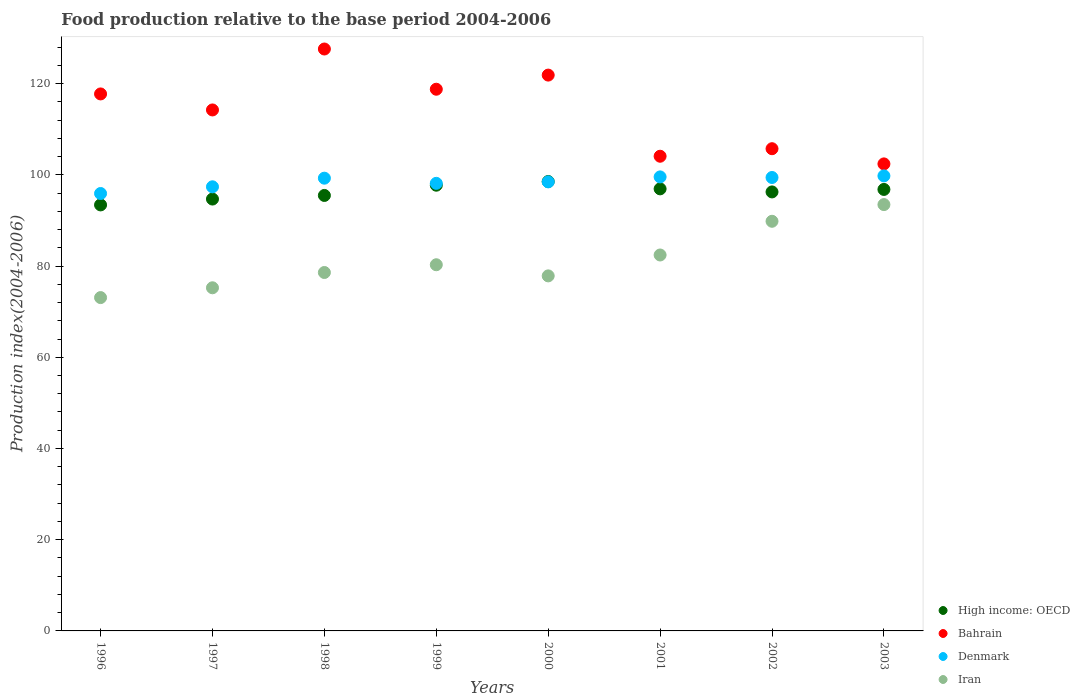Is the number of dotlines equal to the number of legend labels?
Keep it short and to the point. Yes. What is the food production index in Bahrain in 2001?
Give a very brief answer. 104.07. Across all years, what is the maximum food production index in Bahrain?
Make the answer very short. 127.58. Across all years, what is the minimum food production index in Bahrain?
Ensure brevity in your answer.  102.39. In which year was the food production index in Denmark maximum?
Provide a short and direct response. 2003. In which year was the food production index in Bahrain minimum?
Ensure brevity in your answer.  2003. What is the total food production index in Denmark in the graph?
Keep it short and to the point. 787.82. What is the difference between the food production index in Iran in 1996 and that in 1997?
Keep it short and to the point. -2.15. What is the difference between the food production index in Denmark in 2002 and the food production index in High income: OECD in 2001?
Offer a terse response. 2.49. What is the average food production index in Bahrain per year?
Provide a short and direct response. 114.04. In the year 2001, what is the difference between the food production index in High income: OECD and food production index in Denmark?
Your response must be concise. -2.62. What is the ratio of the food production index in Denmark in 1997 to that in 2001?
Your answer should be very brief. 0.98. Is the difference between the food production index in High income: OECD in 1996 and 1998 greater than the difference between the food production index in Denmark in 1996 and 1998?
Your response must be concise. Yes. What is the difference between the highest and the second highest food production index in Denmark?
Provide a short and direct response. 0.22. What is the difference between the highest and the lowest food production index in High income: OECD?
Offer a very short reply. 5.13. In how many years, is the food production index in High income: OECD greater than the average food production index in High income: OECD taken over all years?
Keep it short and to the point. 5. Is the sum of the food production index in Iran in 2000 and 2003 greater than the maximum food production index in Denmark across all years?
Your answer should be compact. Yes. Is it the case that in every year, the sum of the food production index in High income: OECD and food production index in Bahrain  is greater than the food production index in Denmark?
Give a very brief answer. Yes. Does the food production index in Iran monotonically increase over the years?
Provide a succinct answer. No. How many dotlines are there?
Your answer should be very brief. 4. What is the difference between two consecutive major ticks on the Y-axis?
Give a very brief answer. 20. Are the values on the major ticks of Y-axis written in scientific E-notation?
Provide a succinct answer. No. Does the graph contain grids?
Provide a short and direct response. No. Where does the legend appear in the graph?
Offer a terse response. Bottom right. What is the title of the graph?
Make the answer very short. Food production relative to the base period 2004-2006. Does "Barbados" appear as one of the legend labels in the graph?
Ensure brevity in your answer.  No. What is the label or title of the X-axis?
Provide a succinct answer. Years. What is the label or title of the Y-axis?
Keep it short and to the point. Production index(2004-2006). What is the Production index(2004-2006) in High income: OECD in 1996?
Provide a succinct answer. 93.4. What is the Production index(2004-2006) of Bahrain in 1996?
Make the answer very short. 117.73. What is the Production index(2004-2006) of Denmark in 1996?
Provide a short and direct response. 95.9. What is the Production index(2004-2006) of Iran in 1996?
Make the answer very short. 73.08. What is the Production index(2004-2006) of High income: OECD in 1997?
Your response must be concise. 94.68. What is the Production index(2004-2006) of Bahrain in 1997?
Make the answer very short. 114.22. What is the Production index(2004-2006) in Denmark in 1997?
Your answer should be very brief. 97.37. What is the Production index(2004-2006) in Iran in 1997?
Provide a succinct answer. 75.23. What is the Production index(2004-2006) of High income: OECD in 1998?
Make the answer very short. 95.47. What is the Production index(2004-2006) of Bahrain in 1998?
Offer a terse response. 127.58. What is the Production index(2004-2006) of Denmark in 1998?
Your answer should be compact. 99.26. What is the Production index(2004-2006) of Iran in 1998?
Provide a short and direct response. 78.58. What is the Production index(2004-2006) of High income: OECD in 1999?
Ensure brevity in your answer.  97.72. What is the Production index(2004-2006) of Bahrain in 1999?
Offer a very short reply. 118.76. What is the Production index(2004-2006) of Denmark in 1999?
Provide a short and direct response. 98.13. What is the Production index(2004-2006) of Iran in 1999?
Your response must be concise. 80.28. What is the Production index(2004-2006) of High income: OECD in 2000?
Offer a very short reply. 98.53. What is the Production index(2004-2006) in Bahrain in 2000?
Your answer should be very brief. 121.86. What is the Production index(2004-2006) of Denmark in 2000?
Ensure brevity in your answer.  98.45. What is the Production index(2004-2006) of Iran in 2000?
Provide a short and direct response. 77.84. What is the Production index(2004-2006) in High income: OECD in 2001?
Your answer should be compact. 96.92. What is the Production index(2004-2006) in Bahrain in 2001?
Provide a succinct answer. 104.07. What is the Production index(2004-2006) of Denmark in 2001?
Offer a terse response. 99.54. What is the Production index(2004-2006) of Iran in 2001?
Offer a terse response. 82.42. What is the Production index(2004-2006) in High income: OECD in 2002?
Offer a terse response. 96.25. What is the Production index(2004-2006) in Bahrain in 2002?
Offer a very short reply. 105.72. What is the Production index(2004-2006) in Denmark in 2002?
Your answer should be compact. 99.41. What is the Production index(2004-2006) of Iran in 2002?
Offer a terse response. 89.81. What is the Production index(2004-2006) of High income: OECD in 2003?
Your answer should be very brief. 96.79. What is the Production index(2004-2006) in Bahrain in 2003?
Ensure brevity in your answer.  102.39. What is the Production index(2004-2006) in Denmark in 2003?
Your answer should be very brief. 99.76. What is the Production index(2004-2006) of Iran in 2003?
Provide a short and direct response. 93.47. Across all years, what is the maximum Production index(2004-2006) in High income: OECD?
Make the answer very short. 98.53. Across all years, what is the maximum Production index(2004-2006) of Bahrain?
Your response must be concise. 127.58. Across all years, what is the maximum Production index(2004-2006) of Denmark?
Provide a succinct answer. 99.76. Across all years, what is the maximum Production index(2004-2006) of Iran?
Your answer should be very brief. 93.47. Across all years, what is the minimum Production index(2004-2006) in High income: OECD?
Ensure brevity in your answer.  93.4. Across all years, what is the minimum Production index(2004-2006) of Bahrain?
Provide a succinct answer. 102.39. Across all years, what is the minimum Production index(2004-2006) of Denmark?
Offer a very short reply. 95.9. Across all years, what is the minimum Production index(2004-2006) of Iran?
Provide a short and direct response. 73.08. What is the total Production index(2004-2006) of High income: OECD in the graph?
Your answer should be compact. 769.76. What is the total Production index(2004-2006) of Bahrain in the graph?
Your response must be concise. 912.33. What is the total Production index(2004-2006) of Denmark in the graph?
Your answer should be compact. 787.82. What is the total Production index(2004-2006) in Iran in the graph?
Provide a succinct answer. 650.71. What is the difference between the Production index(2004-2006) of High income: OECD in 1996 and that in 1997?
Make the answer very short. -1.28. What is the difference between the Production index(2004-2006) of Bahrain in 1996 and that in 1997?
Provide a succinct answer. 3.51. What is the difference between the Production index(2004-2006) of Denmark in 1996 and that in 1997?
Your response must be concise. -1.47. What is the difference between the Production index(2004-2006) in Iran in 1996 and that in 1997?
Offer a terse response. -2.15. What is the difference between the Production index(2004-2006) in High income: OECD in 1996 and that in 1998?
Give a very brief answer. -2.07. What is the difference between the Production index(2004-2006) in Bahrain in 1996 and that in 1998?
Ensure brevity in your answer.  -9.85. What is the difference between the Production index(2004-2006) of Denmark in 1996 and that in 1998?
Your answer should be compact. -3.36. What is the difference between the Production index(2004-2006) of Iran in 1996 and that in 1998?
Ensure brevity in your answer.  -5.5. What is the difference between the Production index(2004-2006) in High income: OECD in 1996 and that in 1999?
Provide a short and direct response. -4.32. What is the difference between the Production index(2004-2006) of Bahrain in 1996 and that in 1999?
Provide a short and direct response. -1.03. What is the difference between the Production index(2004-2006) of Denmark in 1996 and that in 1999?
Offer a very short reply. -2.23. What is the difference between the Production index(2004-2006) of Iran in 1996 and that in 1999?
Offer a very short reply. -7.2. What is the difference between the Production index(2004-2006) of High income: OECD in 1996 and that in 2000?
Provide a succinct answer. -5.13. What is the difference between the Production index(2004-2006) of Bahrain in 1996 and that in 2000?
Give a very brief answer. -4.13. What is the difference between the Production index(2004-2006) of Denmark in 1996 and that in 2000?
Provide a succinct answer. -2.55. What is the difference between the Production index(2004-2006) in Iran in 1996 and that in 2000?
Your answer should be compact. -4.76. What is the difference between the Production index(2004-2006) of High income: OECD in 1996 and that in 2001?
Provide a short and direct response. -3.52. What is the difference between the Production index(2004-2006) in Bahrain in 1996 and that in 2001?
Ensure brevity in your answer.  13.66. What is the difference between the Production index(2004-2006) of Denmark in 1996 and that in 2001?
Give a very brief answer. -3.64. What is the difference between the Production index(2004-2006) of Iran in 1996 and that in 2001?
Your answer should be very brief. -9.34. What is the difference between the Production index(2004-2006) of High income: OECD in 1996 and that in 2002?
Your response must be concise. -2.85. What is the difference between the Production index(2004-2006) of Bahrain in 1996 and that in 2002?
Ensure brevity in your answer.  12.01. What is the difference between the Production index(2004-2006) of Denmark in 1996 and that in 2002?
Provide a succinct answer. -3.51. What is the difference between the Production index(2004-2006) of Iran in 1996 and that in 2002?
Keep it short and to the point. -16.73. What is the difference between the Production index(2004-2006) in High income: OECD in 1996 and that in 2003?
Make the answer very short. -3.39. What is the difference between the Production index(2004-2006) of Bahrain in 1996 and that in 2003?
Keep it short and to the point. 15.34. What is the difference between the Production index(2004-2006) in Denmark in 1996 and that in 2003?
Offer a terse response. -3.86. What is the difference between the Production index(2004-2006) in Iran in 1996 and that in 2003?
Offer a very short reply. -20.39. What is the difference between the Production index(2004-2006) in High income: OECD in 1997 and that in 1998?
Offer a very short reply. -0.79. What is the difference between the Production index(2004-2006) in Bahrain in 1997 and that in 1998?
Provide a short and direct response. -13.36. What is the difference between the Production index(2004-2006) in Denmark in 1997 and that in 1998?
Offer a very short reply. -1.89. What is the difference between the Production index(2004-2006) of Iran in 1997 and that in 1998?
Ensure brevity in your answer.  -3.35. What is the difference between the Production index(2004-2006) in High income: OECD in 1997 and that in 1999?
Keep it short and to the point. -3.04. What is the difference between the Production index(2004-2006) of Bahrain in 1997 and that in 1999?
Provide a succinct answer. -4.54. What is the difference between the Production index(2004-2006) of Denmark in 1997 and that in 1999?
Your answer should be very brief. -0.76. What is the difference between the Production index(2004-2006) of Iran in 1997 and that in 1999?
Your response must be concise. -5.05. What is the difference between the Production index(2004-2006) of High income: OECD in 1997 and that in 2000?
Your response must be concise. -3.84. What is the difference between the Production index(2004-2006) of Bahrain in 1997 and that in 2000?
Your response must be concise. -7.64. What is the difference between the Production index(2004-2006) in Denmark in 1997 and that in 2000?
Your response must be concise. -1.08. What is the difference between the Production index(2004-2006) of Iran in 1997 and that in 2000?
Provide a short and direct response. -2.61. What is the difference between the Production index(2004-2006) in High income: OECD in 1997 and that in 2001?
Your answer should be very brief. -2.23. What is the difference between the Production index(2004-2006) in Bahrain in 1997 and that in 2001?
Make the answer very short. 10.15. What is the difference between the Production index(2004-2006) in Denmark in 1997 and that in 2001?
Your answer should be compact. -2.17. What is the difference between the Production index(2004-2006) in Iran in 1997 and that in 2001?
Give a very brief answer. -7.19. What is the difference between the Production index(2004-2006) in High income: OECD in 1997 and that in 2002?
Your answer should be compact. -1.56. What is the difference between the Production index(2004-2006) of Denmark in 1997 and that in 2002?
Ensure brevity in your answer.  -2.04. What is the difference between the Production index(2004-2006) of Iran in 1997 and that in 2002?
Keep it short and to the point. -14.58. What is the difference between the Production index(2004-2006) of High income: OECD in 1997 and that in 2003?
Give a very brief answer. -2.11. What is the difference between the Production index(2004-2006) in Bahrain in 1997 and that in 2003?
Offer a very short reply. 11.83. What is the difference between the Production index(2004-2006) in Denmark in 1997 and that in 2003?
Your response must be concise. -2.39. What is the difference between the Production index(2004-2006) in Iran in 1997 and that in 2003?
Provide a short and direct response. -18.24. What is the difference between the Production index(2004-2006) of High income: OECD in 1998 and that in 1999?
Your answer should be compact. -2.25. What is the difference between the Production index(2004-2006) of Bahrain in 1998 and that in 1999?
Provide a short and direct response. 8.82. What is the difference between the Production index(2004-2006) in Denmark in 1998 and that in 1999?
Ensure brevity in your answer.  1.13. What is the difference between the Production index(2004-2006) in High income: OECD in 1998 and that in 2000?
Offer a very short reply. -3.05. What is the difference between the Production index(2004-2006) in Bahrain in 1998 and that in 2000?
Offer a terse response. 5.72. What is the difference between the Production index(2004-2006) of Denmark in 1998 and that in 2000?
Provide a succinct answer. 0.81. What is the difference between the Production index(2004-2006) in Iran in 1998 and that in 2000?
Your response must be concise. 0.74. What is the difference between the Production index(2004-2006) of High income: OECD in 1998 and that in 2001?
Offer a terse response. -1.44. What is the difference between the Production index(2004-2006) of Bahrain in 1998 and that in 2001?
Offer a terse response. 23.51. What is the difference between the Production index(2004-2006) of Denmark in 1998 and that in 2001?
Your response must be concise. -0.28. What is the difference between the Production index(2004-2006) in Iran in 1998 and that in 2001?
Make the answer very short. -3.84. What is the difference between the Production index(2004-2006) in High income: OECD in 1998 and that in 2002?
Keep it short and to the point. -0.77. What is the difference between the Production index(2004-2006) in Bahrain in 1998 and that in 2002?
Make the answer very short. 21.86. What is the difference between the Production index(2004-2006) of Iran in 1998 and that in 2002?
Provide a short and direct response. -11.23. What is the difference between the Production index(2004-2006) in High income: OECD in 1998 and that in 2003?
Keep it short and to the point. -1.32. What is the difference between the Production index(2004-2006) of Bahrain in 1998 and that in 2003?
Make the answer very short. 25.19. What is the difference between the Production index(2004-2006) of Iran in 1998 and that in 2003?
Your response must be concise. -14.89. What is the difference between the Production index(2004-2006) of High income: OECD in 1999 and that in 2000?
Your response must be concise. -0.81. What is the difference between the Production index(2004-2006) in Bahrain in 1999 and that in 2000?
Give a very brief answer. -3.1. What is the difference between the Production index(2004-2006) in Denmark in 1999 and that in 2000?
Keep it short and to the point. -0.32. What is the difference between the Production index(2004-2006) in Iran in 1999 and that in 2000?
Your response must be concise. 2.44. What is the difference between the Production index(2004-2006) of High income: OECD in 1999 and that in 2001?
Give a very brief answer. 0.8. What is the difference between the Production index(2004-2006) of Bahrain in 1999 and that in 2001?
Provide a short and direct response. 14.69. What is the difference between the Production index(2004-2006) of Denmark in 1999 and that in 2001?
Give a very brief answer. -1.41. What is the difference between the Production index(2004-2006) of Iran in 1999 and that in 2001?
Provide a succinct answer. -2.14. What is the difference between the Production index(2004-2006) in High income: OECD in 1999 and that in 2002?
Your answer should be very brief. 1.47. What is the difference between the Production index(2004-2006) of Bahrain in 1999 and that in 2002?
Keep it short and to the point. 13.04. What is the difference between the Production index(2004-2006) of Denmark in 1999 and that in 2002?
Offer a very short reply. -1.28. What is the difference between the Production index(2004-2006) in Iran in 1999 and that in 2002?
Provide a succinct answer. -9.53. What is the difference between the Production index(2004-2006) in High income: OECD in 1999 and that in 2003?
Provide a short and direct response. 0.93. What is the difference between the Production index(2004-2006) in Bahrain in 1999 and that in 2003?
Offer a very short reply. 16.37. What is the difference between the Production index(2004-2006) in Denmark in 1999 and that in 2003?
Your response must be concise. -1.63. What is the difference between the Production index(2004-2006) of Iran in 1999 and that in 2003?
Make the answer very short. -13.19. What is the difference between the Production index(2004-2006) in High income: OECD in 2000 and that in 2001?
Ensure brevity in your answer.  1.61. What is the difference between the Production index(2004-2006) in Bahrain in 2000 and that in 2001?
Ensure brevity in your answer.  17.79. What is the difference between the Production index(2004-2006) of Denmark in 2000 and that in 2001?
Offer a very short reply. -1.09. What is the difference between the Production index(2004-2006) of Iran in 2000 and that in 2001?
Provide a succinct answer. -4.58. What is the difference between the Production index(2004-2006) in High income: OECD in 2000 and that in 2002?
Provide a succinct answer. 2.28. What is the difference between the Production index(2004-2006) of Bahrain in 2000 and that in 2002?
Ensure brevity in your answer.  16.14. What is the difference between the Production index(2004-2006) in Denmark in 2000 and that in 2002?
Provide a succinct answer. -0.96. What is the difference between the Production index(2004-2006) in Iran in 2000 and that in 2002?
Ensure brevity in your answer.  -11.97. What is the difference between the Production index(2004-2006) of High income: OECD in 2000 and that in 2003?
Your answer should be very brief. 1.73. What is the difference between the Production index(2004-2006) of Bahrain in 2000 and that in 2003?
Make the answer very short. 19.47. What is the difference between the Production index(2004-2006) of Denmark in 2000 and that in 2003?
Your answer should be compact. -1.31. What is the difference between the Production index(2004-2006) in Iran in 2000 and that in 2003?
Keep it short and to the point. -15.63. What is the difference between the Production index(2004-2006) in High income: OECD in 2001 and that in 2002?
Offer a very short reply. 0.67. What is the difference between the Production index(2004-2006) of Bahrain in 2001 and that in 2002?
Make the answer very short. -1.65. What is the difference between the Production index(2004-2006) in Denmark in 2001 and that in 2002?
Keep it short and to the point. 0.13. What is the difference between the Production index(2004-2006) in Iran in 2001 and that in 2002?
Provide a short and direct response. -7.39. What is the difference between the Production index(2004-2006) in High income: OECD in 2001 and that in 2003?
Ensure brevity in your answer.  0.12. What is the difference between the Production index(2004-2006) in Bahrain in 2001 and that in 2003?
Offer a terse response. 1.68. What is the difference between the Production index(2004-2006) in Denmark in 2001 and that in 2003?
Give a very brief answer. -0.22. What is the difference between the Production index(2004-2006) of Iran in 2001 and that in 2003?
Keep it short and to the point. -11.05. What is the difference between the Production index(2004-2006) of High income: OECD in 2002 and that in 2003?
Make the answer very short. -0.55. What is the difference between the Production index(2004-2006) in Bahrain in 2002 and that in 2003?
Give a very brief answer. 3.33. What is the difference between the Production index(2004-2006) in Denmark in 2002 and that in 2003?
Your response must be concise. -0.35. What is the difference between the Production index(2004-2006) of Iran in 2002 and that in 2003?
Your answer should be very brief. -3.66. What is the difference between the Production index(2004-2006) of High income: OECD in 1996 and the Production index(2004-2006) of Bahrain in 1997?
Ensure brevity in your answer.  -20.82. What is the difference between the Production index(2004-2006) of High income: OECD in 1996 and the Production index(2004-2006) of Denmark in 1997?
Offer a very short reply. -3.97. What is the difference between the Production index(2004-2006) of High income: OECD in 1996 and the Production index(2004-2006) of Iran in 1997?
Make the answer very short. 18.17. What is the difference between the Production index(2004-2006) of Bahrain in 1996 and the Production index(2004-2006) of Denmark in 1997?
Provide a short and direct response. 20.36. What is the difference between the Production index(2004-2006) of Bahrain in 1996 and the Production index(2004-2006) of Iran in 1997?
Your response must be concise. 42.5. What is the difference between the Production index(2004-2006) of Denmark in 1996 and the Production index(2004-2006) of Iran in 1997?
Keep it short and to the point. 20.67. What is the difference between the Production index(2004-2006) in High income: OECD in 1996 and the Production index(2004-2006) in Bahrain in 1998?
Keep it short and to the point. -34.18. What is the difference between the Production index(2004-2006) in High income: OECD in 1996 and the Production index(2004-2006) in Denmark in 1998?
Keep it short and to the point. -5.86. What is the difference between the Production index(2004-2006) in High income: OECD in 1996 and the Production index(2004-2006) in Iran in 1998?
Offer a terse response. 14.82. What is the difference between the Production index(2004-2006) in Bahrain in 1996 and the Production index(2004-2006) in Denmark in 1998?
Provide a succinct answer. 18.47. What is the difference between the Production index(2004-2006) of Bahrain in 1996 and the Production index(2004-2006) of Iran in 1998?
Ensure brevity in your answer.  39.15. What is the difference between the Production index(2004-2006) of Denmark in 1996 and the Production index(2004-2006) of Iran in 1998?
Ensure brevity in your answer.  17.32. What is the difference between the Production index(2004-2006) of High income: OECD in 1996 and the Production index(2004-2006) of Bahrain in 1999?
Give a very brief answer. -25.36. What is the difference between the Production index(2004-2006) of High income: OECD in 1996 and the Production index(2004-2006) of Denmark in 1999?
Provide a short and direct response. -4.73. What is the difference between the Production index(2004-2006) of High income: OECD in 1996 and the Production index(2004-2006) of Iran in 1999?
Provide a short and direct response. 13.12. What is the difference between the Production index(2004-2006) in Bahrain in 1996 and the Production index(2004-2006) in Denmark in 1999?
Offer a terse response. 19.6. What is the difference between the Production index(2004-2006) of Bahrain in 1996 and the Production index(2004-2006) of Iran in 1999?
Your answer should be very brief. 37.45. What is the difference between the Production index(2004-2006) of Denmark in 1996 and the Production index(2004-2006) of Iran in 1999?
Ensure brevity in your answer.  15.62. What is the difference between the Production index(2004-2006) in High income: OECD in 1996 and the Production index(2004-2006) in Bahrain in 2000?
Give a very brief answer. -28.46. What is the difference between the Production index(2004-2006) in High income: OECD in 1996 and the Production index(2004-2006) in Denmark in 2000?
Make the answer very short. -5.05. What is the difference between the Production index(2004-2006) in High income: OECD in 1996 and the Production index(2004-2006) in Iran in 2000?
Your answer should be very brief. 15.56. What is the difference between the Production index(2004-2006) in Bahrain in 1996 and the Production index(2004-2006) in Denmark in 2000?
Your answer should be very brief. 19.28. What is the difference between the Production index(2004-2006) of Bahrain in 1996 and the Production index(2004-2006) of Iran in 2000?
Offer a very short reply. 39.89. What is the difference between the Production index(2004-2006) of Denmark in 1996 and the Production index(2004-2006) of Iran in 2000?
Give a very brief answer. 18.06. What is the difference between the Production index(2004-2006) in High income: OECD in 1996 and the Production index(2004-2006) in Bahrain in 2001?
Offer a terse response. -10.67. What is the difference between the Production index(2004-2006) in High income: OECD in 1996 and the Production index(2004-2006) in Denmark in 2001?
Keep it short and to the point. -6.14. What is the difference between the Production index(2004-2006) of High income: OECD in 1996 and the Production index(2004-2006) of Iran in 2001?
Your response must be concise. 10.98. What is the difference between the Production index(2004-2006) in Bahrain in 1996 and the Production index(2004-2006) in Denmark in 2001?
Provide a short and direct response. 18.19. What is the difference between the Production index(2004-2006) in Bahrain in 1996 and the Production index(2004-2006) in Iran in 2001?
Offer a very short reply. 35.31. What is the difference between the Production index(2004-2006) in Denmark in 1996 and the Production index(2004-2006) in Iran in 2001?
Give a very brief answer. 13.48. What is the difference between the Production index(2004-2006) of High income: OECD in 1996 and the Production index(2004-2006) of Bahrain in 2002?
Offer a very short reply. -12.32. What is the difference between the Production index(2004-2006) of High income: OECD in 1996 and the Production index(2004-2006) of Denmark in 2002?
Provide a short and direct response. -6.01. What is the difference between the Production index(2004-2006) of High income: OECD in 1996 and the Production index(2004-2006) of Iran in 2002?
Offer a very short reply. 3.59. What is the difference between the Production index(2004-2006) of Bahrain in 1996 and the Production index(2004-2006) of Denmark in 2002?
Provide a succinct answer. 18.32. What is the difference between the Production index(2004-2006) of Bahrain in 1996 and the Production index(2004-2006) of Iran in 2002?
Offer a terse response. 27.92. What is the difference between the Production index(2004-2006) of Denmark in 1996 and the Production index(2004-2006) of Iran in 2002?
Your answer should be compact. 6.09. What is the difference between the Production index(2004-2006) of High income: OECD in 1996 and the Production index(2004-2006) of Bahrain in 2003?
Offer a very short reply. -8.99. What is the difference between the Production index(2004-2006) in High income: OECD in 1996 and the Production index(2004-2006) in Denmark in 2003?
Your response must be concise. -6.36. What is the difference between the Production index(2004-2006) of High income: OECD in 1996 and the Production index(2004-2006) of Iran in 2003?
Keep it short and to the point. -0.07. What is the difference between the Production index(2004-2006) of Bahrain in 1996 and the Production index(2004-2006) of Denmark in 2003?
Ensure brevity in your answer.  17.97. What is the difference between the Production index(2004-2006) in Bahrain in 1996 and the Production index(2004-2006) in Iran in 2003?
Offer a very short reply. 24.26. What is the difference between the Production index(2004-2006) of Denmark in 1996 and the Production index(2004-2006) of Iran in 2003?
Offer a terse response. 2.43. What is the difference between the Production index(2004-2006) in High income: OECD in 1997 and the Production index(2004-2006) in Bahrain in 1998?
Ensure brevity in your answer.  -32.9. What is the difference between the Production index(2004-2006) of High income: OECD in 1997 and the Production index(2004-2006) of Denmark in 1998?
Your answer should be very brief. -4.58. What is the difference between the Production index(2004-2006) in High income: OECD in 1997 and the Production index(2004-2006) in Iran in 1998?
Make the answer very short. 16.1. What is the difference between the Production index(2004-2006) in Bahrain in 1997 and the Production index(2004-2006) in Denmark in 1998?
Your answer should be compact. 14.96. What is the difference between the Production index(2004-2006) of Bahrain in 1997 and the Production index(2004-2006) of Iran in 1998?
Offer a very short reply. 35.64. What is the difference between the Production index(2004-2006) of Denmark in 1997 and the Production index(2004-2006) of Iran in 1998?
Your answer should be compact. 18.79. What is the difference between the Production index(2004-2006) in High income: OECD in 1997 and the Production index(2004-2006) in Bahrain in 1999?
Your response must be concise. -24.08. What is the difference between the Production index(2004-2006) of High income: OECD in 1997 and the Production index(2004-2006) of Denmark in 1999?
Give a very brief answer. -3.45. What is the difference between the Production index(2004-2006) of High income: OECD in 1997 and the Production index(2004-2006) of Iran in 1999?
Provide a short and direct response. 14.4. What is the difference between the Production index(2004-2006) of Bahrain in 1997 and the Production index(2004-2006) of Denmark in 1999?
Provide a succinct answer. 16.09. What is the difference between the Production index(2004-2006) of Bahrain in 1997 and the Production index(2004-2006) of Iran in 1999?
Your response must be concise. 33.94. What is the difference between the Production index(2004-2006) in Denmark in 1997 and the Production index(2004-2006) in Iran in 1999?
Ensure brevity in your answer.  17.09. What is the difference between the Production index(2004-2006) of High income: OECD in 1997 and the Production index(2004-2006) of Bahrain in 2000?
Ensure brevity in your answer.  -27.18. What is the difference between the Production index(2004-2006) in High income: OECD in 1997 and the Production index(2004-2006) in Denmark in 2000?
Your response must be concise. -3.77. What is the difference between the Production index(2004-2006) of High income: OECD in 1997 and the Production index(2004-2006) of Iran in 2000?
Give a very brief answer. 16.84. What is the difference between the Production index(2004-2006) of Bahrain in 1997 and the Production index(2004-2006) of Denmark in 2000?
Your response must be concise. 15.77. What is the difference between the Production index(2004-2006) of Bahrain in 1997 and the Production index(2004-2006) of Iran in 2000?
Offer a terse response. 36.38. What is the difference between the Production index(2004-2006) in Denmark in 1997 and the Production index(2004-2006) in Iran in 2000?
Offer a very short reply. 19.53. What is the difference between the Production index(2004-2006) of High income: OECD in 1997 and the Production index(2004-2006) of Bahrain in 2001?
Provide a succinct answer. -9.39. What is the difference between the Production index(2004-2006) of High income: OECD in 1997 and the Production index(2004-2006) of Denmark in 2001?
Your answer should be very brief. -4.86. What is the difference between the Production index(2004-2006) of High income: OECD in 1997 and the Production index(2004-2006) of Iran in 2001?
Make the answer very short. 12.26. What is the difference between the Production index(2004-2006) in Bahrain in 1997 and the Production index(2004-2006) in Denmark in 2001?
Provide a short and direct response. 14.68. What is the difference between the Production index(2004-2006) of Bahrain in 1997 and the Production index(2004-2006) of Iran in 2001?
Give a very brief answer. 31.8. What is the difference between the Production index(2004-2006) in Denmark in 1997 and the Production index(2004-2006) in Iran in 2001?
Provide a short and direct response. 14.95. What is the difference between the Production index(2004-2006) of High income: OECD in 1997 and the Production index(2004-2006) of Bahrain in 2002?
Make the answer very short. -11.04. What is the difference between the Production index(2004-2006) in High income: OECD in 1997 and the Production index(2004-2006) in Denmark in 2002?
Offer a terse response. -4.73. What is the difference between the Production index(2004-2006) in High income: OECD in 1997 and the Production index(2004-2006) in Iran in 2002?
Your answer should be compact. 4.87. What is the difference between the Production index(2004-2006) of Bahrain in 1997 and the Production index(2004-2006) of Denmark in 2002?
Provide a succinct answer. 14.81. What is the difference between the Production index(2004-2006) of Bahrain in 1997 and the Production index(2004-2006) of Iran in 2002?
Provide a short and direct response. 24.41. What is the difference between the Production index(2004-2006) of Denmark in 1997 and the Production index(2004-2006) of Iran in 2002?
Your answer should be very brief. 7.56. What is the difference between the Production index(2004-2006) in High income: OECD in 1997 and the Production index(2004-2006) in Bahrain in 2003?
Provide a short and direct response. -7.71. What is the difference between the Production index(2004-2006) in High income: OECD in 1997 and the Production index(2004-2006) in Denmark in 2003?
Keep it short and to the point. -5.08. What is the difference between the Production index(2004-2006) in High income: OECD in 1997 and the Production index(2004-2006) in Iran in 2003?
Provide a succinct answer. 1.21. What is the difference between the Production index(2004-2006) of Bahrain in 1997 and the Production index(2004-2006) of Denmark in 2003?
Ensure brevity in your answer.  14.46. What is the difference between the Production index(2004-2006) in Bahrain in 1997 and the Production index(2004-2006) in Iran in 2003?
Keep it short and to the point. 20.75. What is the difference between the Production index(2004-2006) in High income: OECD in 1998 and the Production index(2004-2006) in Bahrain in 1999?
Your response must be concise. -23.29. What is the difference between the Production index(2004-2006) in High income: OECD in 1998 and the Production index(2004-2006) in Denmark in 1999?
Your answer should be compact. -2.66. What is the difference between the Production index(2004-2006) of High income: OECD in 1998 and the Production index(2004-2006) of Iran in 1999?
Provide a short and direct response. 15.19. What is the difference between the Production index(2004-2006) of Bahrain in 1998 and the Production index(2004-2006) of Denmark in 1999?
Make the answer very short. 29.45. What is the difference between the Production index(2004-2006) in Bahrain in 1998 and the Production index(2004-2006) in Iran in 1999?
Offer a very short reply. 47.3. What is the difference between the Production index(2004-2006) of Denmark in 1998 and the Production index(2004-2006) of Iran in 1999?
Offer a terse response. 18.98. What is the difference between the Production index(2004-2006) in High income: OECD in 1998 and the Production index(2004-2006) in Bahrain in 2000?
Ensure brevity in your answer.  -26.39. What is the difference between the Production index(2004-2006) in High income: OECD in 1998 and the Production index(2004-2006) in Denmark in 2000?
Your answer should be compact. -2.98. What is the difference between the Production index(2004-2006) of High income: OECD in 1998 and the Production index(2004-2006) of Iran in 2000?
Your response must be concise. 17.63. What is the difference between the Production index(2004-2006) in Bahrain in 1998 and the Production index(2004-2006) in Denmark in 2000?
Provide a succinct answer. 29.13. What is the difference between the Production index(2004-2006) of Bahrain in 1998 and the Production index(2004-2006) of Iran in 2000?
Offer a very short reply. 49.74. What is the difference between the Production index(2004-2006) of Denmark in 1998 and the Production index(2004-2006) of Iran in 2000?
Give a very brief answer. 21.42. What is the difference between the Production index(2004-2006) of High income: OECD in 1998 and the Production index(2004-2006) of Bahrain in 2001?
Give a very brief answer. -8.6. What is the difference between the Production index(2004-2006) in High income: OECD in 1998 and the Production index(2004-2006) in Denmark in 2001?
Provide a short and direct response. -4.07. What is the difference between the Production index(2004-2006) in High income: OECD in 1998 and the Production index(2004-2006) in Iran in 2001?
Your answer should be very brief. 13.05. What is the difference between the Production index(2004-2006) of Bahrain in 1998 and the Production index(2004-2006) of Denmark in 2001?
Your answer should be very brief. 28.04. What is the difference between the Production index(2004-2006) of Bahrain in 1998 and the Production index(2004-2006) of Iran in 2001?
Ensure brevity in your answer.  45.16. What is the difference between the Production index(2004-2006) in Denmark in 1998 and the Production index(2004-2006) in Iran in 2001?
Your answer should be very brief. 16.84. What is the difference between the Production index(2004-2006) of High income: OECD in 1998 and the Production index(2004-2006) of Bahrain in 2002?
Offer a terse response. -10.25. What is the difference between the Production index(2004-2006) in High income: OECD in 1998 and the Production index(2004-2006) in Denmark in 2002?
Offer a very short reply. -3.94. What is the difference between the Production index(2004-2006) in High income: OECD in 1998 and the Production index(2004-2006) in Iran in 2002?
Your response must be concise. 5.66. What is the difference between the Production index(2004-2006) in Bahrain in 1998 and the Production index(2004-2006) in Denmark in 2002?
Keep it short and to the point. 28.17. What is the difference between the Production index(2004-2006) of Bahrain in 1998 and the Production index(2004-2006) of Iran in 2002?
Offer a terse response. 37.77. What is the difference between the Production index(2004-2006) of Denmark in 1998 and the Production index(2004-2006) of Iran in 2002?
Offer a terse response. 9.45. What is the difference between the Production index(2004-2006) in High income: OECD in 1998 and the Production index(2004-2006) in Bahrain in 2003?
Offer a terse response. -6.92. What is the difference between the Production index(2004-2006) of High income: OECD in 1998 and the Production index(2004-2006) of Denmark in 2003?
Offer a terse response. -4.29. What is the difference between the Production index(2004-2006) in High income: OECD in 1998 and the Production index(2004-2006) in Iran in 2003?
Make the answer very short. 2. What is the difference between the Production index(2004-2006) in Bahrain in 1998 and the Production index(2004-2006) in Denmark in 2003?
Provide a succinct answer. 27.82. What is the difference between the Production index(2004-2006) in Bahrain in 1998 and the Production index(2004-2006) in Iran in 2003?
Offer a terse response. 34.11. What is the difference between the Production index(2004-2006) in Denmark in 1998 and the Production index(2004-2006) in Iran in 2003?
Offer a very short reply. 5.79. What is the difference between the Production index(2004-2006) of High income: OECD in 1999 and the Production index(2004-2006) of Bahrain in 2000?
Offer a very short reply. -24.14. What is the difference between the Production index(2004-2006) in High income: OECD in 1999 and the Production index(2004-2006) in Denmark in 2000?
Keep it short and to the point. -0.73. What is the difference between the Production index(2004-2006) of High income: OECD in 1999 and the Production index(2004-2006) of Iran in 2000?
Give a very brief answer. 19.88. What is the difference between the Production index(2004-2006) of Bahrain in 1999 and the Production index(2004-2006) of Denmark in 2000?
Provide a short and direct response. 20.31. What is the difference between the Production index(2004-2006) of Bahrain in 1999 and the Production index(2004-2006) of Iran in 2000?
Offer a very short reply. 40.92. What is the difference between the Production index(2004-2006) of Denmark in 1999 and the Production index(2004-2006) of Iran in 2000?
Your answer should be compact. 20.29. What is the difference between the Production index(2004-2006) in High income: OECD in 1999 and the Production index(2004-2006) in Bahrain in 2001?
Provide a short and direct response. -6.35. What is the difference between the Production index(2004-2006) of High income: OECD in 1999 and the Production index(2004-2006) of Denmark in 2001?
Provide a short and direct response. -1.82. What is the difference between the Production index(2004-2006) in High income: OECD in 1999 and the Production index(2004-2006) in Iran in 2001?
Offer a terse response. 15.3. What is the difference between the Production index(2004-2006) in Bahrain in 1999 and the Production index(2004-2006) in Denmark in 2001?
Your answer should be compact. 19.22. What is the difference between the Production index(2004-2006) of Bahrain in 1999 and the Production index(2004-2006) of Iran in 2001?
Offer a very short reply. 36.34. What is the difference between the Production index(2004-2006) of Denmark in 1999 and the Production index(2004-2006) of Iran in 2001?
Provide a short and direct response. 15.71. What is the difference between the Production index(2004-2006) of High income: OECD in 1999 and the Production index(2004-2006) of Bahrain in 2002?
Offer a terse response. -8. What is the difference between the Production index(2004-2006) of High income: OECD in 1999 and the Production index(2004-2006) of Denmark in 2002?
Keep it short and to the point. -1.69. What is the difference between the Production index(2004-2006) of High income: OECD in 1999 and the Production index(2004-2006) of Iran in 2002?
Provide a succinct answer. 7.91. What is the difference between the Production index(2004-2006) of Bahrain in 1999 and the Production index(2004-2006) of Denmark in 2002?
Ensure brevity in your answer.  19.35. What is the difference between the Production index(2004-2006) in Bahrain in 1999 and the Production index(2004-2006) in Iran in 2002?
Give a very brief answer. 28.95. What is the difference between the Production index(2004-2006) in Denmark in 1999 and the Production index(2004-2006) in Iran in 2002?
Give a very brief answer. 8.32. What is the difference between the Production index(2004-2006) in High income: OECD in 1999 and the Production index(2004-2006) in Bahrain in 2003?
Make the answer very short. -4.67. What is the difference between the Production index(2004-2006) in High income: OECD in 1999 and the Production index(2004-2006) in Denmark in 2003?
Provide a succinct answer. -2.04. What is the difference between the Production index(2004-2006) in High income: OECD in 1999 and the Production index(2004-2006) in Iran in 2003?
Your answer should be very brief. 4.25. What is the difference between the Production index(2004-2006) in Bahrain in 1999 and the Production index(2004-2006) in Denmark in 2003?
Provide a succinct answer. 19. What is the difference between the Production index(2004-2006) of Bahrain in 1999 and the Production index(2004-2006) of Iran in 2003?
Your answer should be compact. 25.29. What is the difference between the Production index(2004-2006) in Denmark in 1999 and the Production index(2004-2006) in Iran in 2003?
Provide a succinct answer. 4.66. What is the difference between the Production index(2004-2006) of High income: OECD in 2000 and the Production index(2004-2006) of Bahrain in 2001?
Your answer should be compact. -5.54. What is the difference between the Production index(2004-2006) in High income: OECD in 2000 and the Production index(2004-2006) in Denmark in 2001?
Give a very brief answer. -1.01. What is the difference between the Production index(2004-2006) of High income: OECD in 2000 and the Production index(2004-2006) of Iran in 2001?
Give a very brief answer. 16.11. What is the difference between the Production index(2004-2006) of Bahrain in 2000 and the Production index(2004-2006) of Denmark in 2001?
Ensure brevity in your answer.  22.32. What is the difference between the Production index(2004-2006) of Bahrain in 2000 and the Production index(2004-2006) of Iran in 2001?
Keep it short and to the point. 39.44. What is the difference between the Production index(2004-2006) of Denmark in 2000 and the Production index(2004-2006) of Iran in 2001?
Make the answer very short. 16.03. What is the difference between the Production index(2004-2006) of High income: OECD in 2000 and the Production index(2004-2006) of Bahrain in 2002?
Keep it short and to the point. -7.19. What is the difference between the Production index(2004-2006) of High income: OECD in 2000 and the Production index(2004-2006) of Denmark in 2002?
Give a very brief answer. -0.88. What is the difference between the Production index(2004-2006) of High income: OECD in 2000 and the Production index(2004-2006) of Iran in 2002?
Your response must be concise. 8.72. What is the difference between the Production index(2004-2006) of Bahrain in 2000 and the Production index(2004-2006) of Denmark in 2002?
Your response must be concise. 22.45. What is the difference between the Production index(2004-2006) in Bahrain in 2000 and the Production index(2004-2006) in Iran in 2002?
Offer a very short reply. 32.05. What is the difference between the Production index(2004-2006) in Denmark in 2000 and the Production index(2004-2006) in Iran in 2002?
Your answer should be very brief. 8.64. What is the difference between the Production index(2004-2006) in High income: OECD in 2000 and the Production index(2004-2006) in Bahrain in 2003?
Offer a very short reply. -3.86. What is the difference between the Production index(2004-2006) in High income: OECD in 2000 and the Production index(2004-2006) in Denmark in 2003?
Your answer should be very brief. -1.23. What is the difference between the Production index(2004-2006) of High income: OECD in 2000 and the Production index(2004-2006) of Iran in 2003?
Ensure brevity in your answer.  5.06. What is the difference between the Production index(2004-2006) of Bahrain in 2000 and the Production index(2004-2006) of Denmark in 2003?
Keep it short and to the point. 22.1. What is the difference between the Production index(2004-2006) of Bahrain in 2000 and the Production index(2004-2006) of Iran in 2003?
Make the answer very short. 28.39. What is the difference between the Production index(2004-2006) in Denmark in 2000 and the Production index(2004-2006) in Iran in 2003?
Give a very brief answer. 4.98. What is the difference between the Production index(2004-2006) of High income: OECD in 2001 and the Production index(2004-2006) of Bahrain in 2002?
Ensure brevity in your answer.  -8.8. What is the difference between the Production index(2004-2006) of High income: OECD in 2001 and the Production index(2004-2006) of Denmark in 2002?
Your answer should be compact. -2.49. What is the difference between the Production index(2004-2006) of High income: OECD in 2001 and the Production index(2004-2006) of Iran in 2002?
Offer a terse response. 7.11. What is the difference between the Production index(2004-2006) of Bahrain in 2001 and the Production index(2004-2006) of Denmark in 2002?
Give a very brief answer. 4.66. What is the difference between the Production index(2004-2006) of Bahrain in 2001 and the Production index(2004-2006) of Iran in 2002?
Keep it short and to the point. 14.26. What is the difference between the Production index(2004-2006) of Denmark in 2001 and the Production index(2004-2006) of Iran in 2002?
Ensure brevity in your answer.  9.73. What is the difference between the Production index(2004-2006) in High income: OECD in 2001 and the Production index(2004-2006) in Bahrain in 2003?
Your response must be concise. -5.47. What is the difference between the Production index(2004-2006) in High income: OECD in 2001 and the Production index(2004-2006) in Denmark in 2003?
Offer a terse response. -2.84. What is the difference between the Production index(2004-2006) of High income: OECD in 2001 and the Production index(2004-2006) of Iran in 2003?
Your response must be concise. 3.45. What is the difference between the Production index(2004-2006) in Bahrain in 2001 and the Production index(2004-2006) in Denmark in 2003?
Provide a succinct answer. 4.31. What is the difference between the Production index(2004-2006) in Bahrain in 2001 and the Production index(2004-2006) in Iran in 2003?
Provide a short and direct response. 10.6. What is the difference between the Production index(2004-2006) of Denmark in 2001 and the Production index(2004-2006) of Iran in 2003?
Keep it short and to the point. 6.07. What is the difference between the Production index(2004-2006) in High income: OECD in 2002 and the Production index(2004-2006) in Bahrain in 2003?
Your response must be concise. -6.14. What is the difference between the Production index(2004-2006) in High income: OECD in 2002 and the Production index(2004-2006) in Denmark in 2003?
Your answer should be very brief. -3.51. What is the difference between the Production index(2004-2006) in High income: OECD in 2002 and the Production index(2004-2006) in Iran in 2003?
Provide a succinct answer. 2.78. What is the difference between the Production index(2004-2006) in Bahrain in 2002 and the Production index(2004-2006) in Denmark in 2003?
Give a very brief answer. 5.96. What is the difference between the Production index(2004-2006) in Bahrain in 2002 and the Production index(2004-2006) in Iran in 2003?
Ensure brevity in your answer.  12.25. What is the difference between the Production index(2004-2006) in Denmark in 2002 and the Production index(2004-2006) in Iran in 2003?
Your answer should be compact. 5.94. What is the average Production index(2004-2006) in High income: OECD per year?
Make the answer very short. 96.22. What is the average Production index(2004-2006) of Bahrain per year?
Keep it short and to the point. 114.04. What is the average Production index(2004-2006) of Denmark per year?
Keep it short and to the point. 98.48. What is the average Production index(2004-2006) in Iran per year?
Offer a terse response. 81.34. In the year 1996, what is the difference between the Production index(2004-2006) in High income: OECD and Production index(2004-2006) in Bahrain?
Make the answer very short. -24.33. In the year 1996, what is the difference between the Production index(2004-2006) of High income: OECD and Production index(2004-2006) of Denmark?
Your answer should be compact. -2.5. In the year 1996, what is the difference between the Production index(2004-2006) in High income: OECD and Production index(2004-2006) in Iran?
Your answer should be compact. 20.32. In the year 1996, what is the difference between the Production index(2004-2006) in Bahrain and Production index(2004-2006) in Denmark?
Your answer should be very brief. 21.83. In the year 1996, what is the difference between the Production index(2004-2006) in Bahrain and Production index(2004-2006) in Iran?
Offer a terse response. 44.65. In the year 1996, what is the difference between the Production index(2004-2006) in Denmark and Production index(2004-2006) in Iran?
Make the answer very short. 22.82. In the year 1997, what is the difference between the Production index(2004-2006) in High income: OECD and Production index(2004-2006) in Bahrain?
Your answer should be compact. -19.54. In the year 1997, what is the difference between the Production index(2004-2006) of High income: OECD and Production index(2004-2006) of Denmark?
Offer a very short reply. -2.69. In the year 1997, what is the difference between the Production index(2004-2006) of High income: OECD and Production index(2004-2006) of Iran?
Keep it short and to the point. 19.45. In the year 1997, what is the difference between the Production index(2004-2006) in Bahrain and Production index(2004-2006) in Denmark?
Provide a succinct answer. 16.85. In the year 1997, what is the difference between the Production index(2004-2006) in Bahrain and Production index(2004-2006) in Iran?
Ensure brevity in your answer.  38.99. In the year 1997, what is the difference between the Production index(2004-2006) of Denmark and Production index(2004-2006) of Iran?
Offer a terse response. 22.14. In the year 1998, what is the difference between the Production index(2004-2006) of High income: OECD and Production index(2004-2006) of Bahrain?
Offer a terse response. -32.11. In the year 1998, what is the difference between the Production index(2004-2006) in High income: OECD and Production index(2004-2006) in Denmark?
Make the answer very short. -3.79. In the year 1998, what is the difference between the Production index(2004-2006) of High income: OECD and Production index(2004-2006) of Iran?
Provide a short and direct response. 16.89. In the year 1998, what is the difference between the Production index(2004-2006) of Bahrain and Production index(2004-2006) of Denmark?
Your response must be concise. 28.32. In the year 1998, what is the difference between the Production index(2004-2006) of Denmark and Production index(2004-2006) of Iran?
Ensure brevity in your answer.  20.68. In the year 1999, what is the difference between the Production index(2004-2006) of High income: OECD and Production index(2004-2006) of Bahrain?
Your response must be concise. -21.04. In the year 1999, what is the difference between the Production index(2004-2006) of High income: OECD and Production index(2004-2006) of Denmark?
Provide a succinct answer. -0.41. In the year 1999, what is the difference between the Production index(2004-2006) of High income: OECD and Production index(2004-2006) of Iran?
Provide a short and direct response. 17.44. In the year 1999, what is the difference between the Production index(2004-2006) in Bahrain and Production index(2004-2006) in Denmark?
Your answer should be very brief. 20.63. In the year 1999, what is the difference between the Production index(2004-2006) in Bahrain and Production index(2004-2006) in Iran?
Provide a short and direct response. 38.48. In the year 1999, what is the difference between the Production index(2004-2006) in Denmark and Production index(2004-2006) in Iran?
Make the answer very short. 17.85. In the year 2000, what is the difference between the Production index(2004-2006) in High income: OECD and Production index(2004-2006) in Bahrain?
Ensure brevity in your answer.  -23.33. In the year 2000, what is the difference between the Production index(2004-2006) in High income: OECD and Production index(2004-2006) in Denmark?
Your response must be concise. 0.08. In the year 2000, what is the difference between the Production index(2004-2006) in High income: OECD and Production index(2004-2006) in Iran?
Provide a succinct answer. 20.69. In the year 2000, what is the difference between the Production index(2004-2006) in Bahrain and Production index(2004-2006) in Denmark?
Your answer should be compact. 23.41. In the year 2000, what is the difference between the Production index(2004-2006) in Bahrain and Production index(2004-2006) in Iran?
Your answer should be very brief. 44.02. In the year 2000, what is the difference between the Production index(2004-2006) of Denmark and Production index(2004-2006) of Iran?
Your response must be concise. 20.61. In the year 2001, what is the difference between the Production index(2004-2006) in High income: OECD and Production index(2004-2006) in Bahrain?
Make the answer very short. -7.15. In the year 2001, what is the difference between the Production index(2004-2006) of High income: OECD and Production index(2004-2006) of Denmark?
Offer a terse response. -2.62. In the year 2001, what is the difference between the Production index(2004-2006) in High income: OECD and Production index(2004-2006) in Iran?
Provide a succinct answer. 14.5. In the year 2001, what is the difference between the Production index(2004-2006) of Bahrain and Production index(2004-2006) of Denmark?
Keep it short and to the point. 4.53. In the year 2001, what is the difference between the Production index(2004-2006) in Bahrain and Production index(2004-2006) in Iran?
Provide a short and direct response. 21.65. In the year 2001, what is the difference between the Production index(2004-2006) of Denmark and Production index(2004-2006) of Iran?
Ensure brevity in your answer.  17.12. In the year 2002, what is the difference between the Production index(2004-2006) in High income: OECD and Production index(2004-2006) in Bahrain?
Give a very brief answer. -9.47. In the year 2002, what is the difference between the Production index(2004-2006) of High income: OECD and Production index(2004-2006) of Denmark?
Offer a very short reply. -3.16. In the year 2002, what is the difference between the Production index(2004-2006) of High income: OECD and Production index(2004-2006) of Iran?
Provide a succinct answer. 6.44. In the year 2002, what is the difference between the Production index(2004-2006) of Bahrain and Production index(2004-2006) of Denmark?
Keep it short and to the point. 6.31. In the year 2002, what is the difference between the Production index(2004-2006) of Bahrain and Production index(2004-2006) of Iran?
Offer a very short reply. 15.91. In the year 2002, what is the difference between the Production index(2004-2006) in Denmark and Production index(2004-2006) in Iran?
Make the answer very short. 9.6. In the year 2003, what is the difference between the Production index(2004-2006) in High income: OECD and Production index(2004-2006) in Bahrain?
Make the answer very short. -5.6. In the year 2003, what is the difference between the Production index(2004-2006) of High income: OECD and Production index(2004-2006) of Denmark?
Keep it short and to the point. -2.97. In the year 2003, what is the difference between the Production index(2004-2006) in High income: OECD and Production index(2004-2006) in Iran?
Offer a very short reply. 3.32. In the year 2003, what is the difference between the Production index(2004-2006) in Bahrain and Production index(2004-2006) in Denmark?
Provide a succinct answer. 2.63. In the year 2003, what is the difference between the Production index(2004-2006) in Bahrain and Production index(2004-2006) in Iran?
Your response must be concise. 8.92. In the year 2003, what is the difference between the Production index(2004-2006) in Denmark and Production index(2004-2006) in Iran?
Offer a very short reply. 6.29. What is the ratio of the Production index(2004-2006) in High income: OECD in 1996 to that in 1997?
Give a very brief answer. 0.99. What is the ratio of the Production index(2004-2006) of Bahrain in 1996 to that in 1997?
Provide a short and direct response. 1.03. What is the ratio of the Production index(2004-2006) in Denmark in 1996 to that in 1997?
Provide a succinct answer. 0.98. What is the ratio of the Production index(2004-2006) of Iran in 1996 to that in 1997?
Your answer should be compact. 0.97. What is the ratio of the Production index(2004-2006) of High income: OECD in 1996 to that in 1998?
Keep it short and to the point. 0.98. What is the ratio of the Production index(2004-2006) of Bahrain in 1996 to that in 1998?
Make the answer very short. 0.92. What is the ratio of the Production index(2004-2006) of Denmark in 1996 to that in 1998?
Keep it short and to the point. 0.97. What is the ratio of the Production index(2004-2006) in Iran in 1996 to that in 1998?
Offer a very short reply. 0.93. What is the ratio of the Production index(2004-2006) in High income: OECD in 1996 to that in 1999?
Provide a succinct answer. 0.96. What is the ratio of the Production index(2004-2006) in Denmark in 1996 to that in 1999?
Provide a succinct answer. 0.98. What is the ratio of the Production index(2004-2006) of Iran in 1996 to that in 1999?
Ensure brevity in your answer.  0.91. What is the ratio of the Production index(2004-2006) in High income: OECD in 1996 to that in 2000?
Give a very brief answer. 0.95. What is the ratio of the Production index(2004-2006) of Bahrain in 1996 to that in 2000?
Your response must be concise. 0.97. What is the ratio of the Production index(2004-2006) of Denmark in 1996 to that in 2000?
Offer a terse response. 0.97. What is the ratio of the Production index(2004-2006) in Iran in 1996 to that in 2000?
Your answer should be very brief. 0.94. What is the ratio of the Production index(2004-2006) in High income: OECD in 1996 to that in 2001?
Give a very brief answer. 0.96. What is the ratio of the Production index(2004-2006) in Bahrain in 1996 to that in 2001?
Make the answer very short. 1.13. What is the ratio of the Production index(2004-2006) in Denmark in 1996 to that in 2001?
Ensure brevity in your answer.  0.96. What is the ratio of the Production index(2004-2006) in Iran in 1996 to that in 2001?
Your answer should be compact. 0.89. What is the ratio of the Production index(2004-2006) of High income: OECD in 1996 to that in 2002?
Provide a succinct answer. 0.97. What is the ratio of the Production index(2004-2006) in Bahrain in 1996 to that in 2002?
Ensure brevity in your answer.  1.11. What is the ratio of the Production index(2004-2006) of Denmark in 1996 to that in 2002?
Offer a very short reply. 0.96. What is the ratio of the Production index(2004-2006) in Iran in 1996 to that in 2002?
Your response must be concise. 0.81. What is the ratio of the Production index(2004-2006) of High income: OECD in 1996 to that in 2003?
Offer a very short reply. 0.96. What is the ratio of the Production index(2004-2006) of Bahrain in 1996 to that in 2003?
Offer a very short reply. 1.15. What is the ratio of the Production index(2004-2006) of Denmark in 1996 to that in 2003?
Ensure brevity in your answer.  0.96. What is the ratio of the Production index(2004-2006) in Iran in 1996 to that in 2003?
Provide a succinct answer. 0.78. What is the ratio of the Production index(2004-2006) in Bahrain in 1997 to that in 1998?
Make the answer very short. 0.9. What is the ratio of the Production index(2004-2006) in Iran in 1997 to that in 1998?
Give a very brief answer. 0.96. What is the ratio of the Production index(2004-2006) in High income: OECD in 1997 to that in 1999?
Your response must be concise. 0.97. What is the ratio of the Production index(2004-2006) in Bahrain in 1997 to that in 1999?
Give a very brief answer. 0.96. What is the ratio of the Production index(2004-2006) of Denmark in 1997 to that in 1999?
Ensure brevity in your answer.  0.99. What is the ratio of the Production index(2004-2006) of Iran in 1997 to that in 1999?
Your response must be concise. 0.94. What is the ratio of the Production index(2004-2006) of High income: OECD in 1997 to that in 2000?
Ensure brevity in your answer.  0.96. What is the ratio of the Production index(2004-2006) of Bahrain in 1997 to that in 2000?
Provide a short and direct response. 0.94. What is the ratio of the Production index(2004-2006) in Denmark in 1997 to that in 2000?
Make the answer very short. 0.99. What is the ratio of the Production index(2004-2006) in Iran in 1997 to that in 2000?
Offer a terse response. 0.97. What is the ratio of the Production index(2004-2006) in High income: OECD in 1997 to that in 2001?
Your answer should be compact. 0.98. What is the ratio of the Production index(2004-2006) in Bahrain in 1997 to that in 2001?
Keep it short and to the point. 1.1. What is the ratio of the Production index(2004-2006) of Denmark in 1997 to that in 2001?
Your response must be concise. 0.98. What is the ratio of the Production index(2004-2006) of Iran in 1997 to that in 2001?
Give a very brief answer. 0.91. What is the ratio of the Production index(2004-2006) of High income: OECD in 1997 to that in 2002?
Offer a very short reply. 0.98. What is the ratio of the Production index(2004-2006) in Bahrain in 1997 to that in 2002?
Offer a terse response. 1.08. What is the ratio of the Production index(2004-2006) in Denmark in 1997 to that in 2002?
Keep it short and to the point. 0.98. What is the ratio of the Production index(2004-2006) of Iran in 1997 to that in 2002?
Offer a terse response. 0.84. What is the ratio of the Production index(2004-2006) in High income: OECD in 1997 to that in 2003?
Give a very brief answer. 0.98. What is the ratio of the Production index(2004-2006) in Bahrain in 1997 to that in 2003?
Make the answer very short. 1.12. What is the ratio of the Production index(2004-2006) in Iran in 1997 to that in 2003?
Your answer should be very brief. 0.8. What is the ratio of the Production index(2004-2006) of Bahrain in 1998 to that in 1999?
Your answer should be compact. 1.07. What is the ratio of the Production index(2004-2006) of Denmark in 1998 to that in 1999?
Your answer should be very brief. 1.01. What is the ratio of the Production index(2004-2006) in Iran in 1998 to that in 1999?
Keep it short and to the point. 0.98. What is the ratio of the Production index(2004-2006) of High income: OECD in 1998 to that in 2000?
Your answer should be compact. 0.97. What is the ratio of the Production index(2004-2006) of Bahrain in 1998 to that in 2000?
Provide a succinct answer. 1.05. What is the ratio of the Production index(2004-2006) of Denmark in 1998 to that in 2000?
Provide a succinct answer. 1.01. What is the ratio of the Production index(2004-2006) of Iran in 1998 to that in 2000?
Keep it short and to the point. 1.01. What is the ratio of the Production index(2004-2006) in High income: OECD in 1998 to that in 2001?
Make the answer very short. 0.99. What is the ratio of the Production index(2004-2006) of Bahrain in 1998 to that in 2001?
Provide a succinct answer. 1.23. What is the ratio of the Production index(2004-2006) in Denmark in 1998 to that in 2001?
Provide a succinct answer. 1. What is the ratio of the Production index(2004-2006) in Iran in 1998 to that in 2001?
Keep it short and to the point. 0.95. What is the ratio of the Production index(2004-2006) of High income: OECD in 1998 to that in 2002?
Offer a terse response. 0.99. What is the ratio of the Production index(2004-2006) of Bahrain in 1998 to that in 2002?
Make the answer very short. 1.21. What is the ratio of the Production index(2004-2006) of Denmark in 1998 to that in 2002?
Give a very brief answer. 1. What is the ratio of the Production index(2004-2006) of Iran in 1998 to that in 2002?
Your answer should be very brief. 0.88. What is the ratio of the Production index(2004-2006) of High income: OECD in 1998 to that in 2003?
Offer a very short reply. 0.99. What is the ratio of the Production index(2004-2006) in Bahrain in 1998 to that in 2003?
Keep it short and to the point. 1.25. What is the ratio of the Production index(2004-2006) of Denmark in 1998 to that in 2003?
Your response must be concise. 0.99. What is the ratio of the Production index(2004-2006) of Iran in 1998 to that in 2003?
Keep it short and to the point. 0.84. What is the ratio of the Production index(2004-2006) of Bahrain in 1999 to that in 2000?
Provide a short and direct response. 0.97. What is the ratio of the Production index(2004-2006) in Iran in 1999 to that in 2000?
Ensure brevity in your answer.  1.03. What is the ratio of the Production index(2004-2006) in High income: OECD in 1999 to that in 2001?
Your answer should be compact. 1.01. What is the ratio of the Production index(2004-2006) in Bahrain in 1999 to that in 2001?
Your answer should be compact. 1.14. What is the ratio of the Production index(2004-2006) of Denmark in 1999 to that in 2001?
Offer a terse response. 0.99. What is the ratio of the Production index(2004-2006) of Iran in 1999 to that in 2001?
Keep it short and to the point. 0.97. What is the ratio of the Production index(2004-2006) in High income: OECD in 1999 to that in 2002?
Make the answer very short. 1.02. What is the ratio of the Production index(2004-2006) in Bahrain in 1999 to that in 2002?
Ensure brevity in your answer.  1.12. What is the ratio of the Production index(2004-2006) of Denmark in 1999 to that in 2002?
Your response must be concise. 0.99. What is the ratio of the Production index(2004-2006) of Iran in 1999 to that in 2002?
Offer a very short reply. 0.89. What is the ratio of the Production index(2004-2006) of High income: OECD in 1999 to that in 2003?
Make the answer very short. 1.01. What is the ratio of the Production index(2004-2006) of Bahrain in 1999 to that in 2003?
Your response must be concise. 1.16. What is the ratio of the Production index(2004-2006) in Denmark in 1999 to that in 2003?
Ensure brevity in your answer.  0.98. What is the ratio of the Production index(2004-2006) of Iran in 1999 to that in 2003?
Keep it short and to the point. 0.86. What is the ratio of the Production index(2004-2006) in High income: OECD in 2000 to that in 2001?
Ensure brevity in your answer.  1.02. What is the ratio of the Production index(2004-2006) in Bahrain in 2000 to that in 2001?
Provide a short and direct response. 1.17. What is the ratio of the Production index(2004-2006) in Denmark in 2000 to that in 2001?
Your answer should be compact. 0.99. What is the ratio of the Production index(2004-2006) of High income: OECD in 2000 to that in 2002?
Offer a very short reply. 1.02. What is the ratio of the Production index(2004-2006) of Bahrain in 2000 to that in 2002?
Make the answer very short. 1.15. What is the ratio of the Production index(2004-2006) of Denmark in 2000 to that in 2002?
Provide a succinct answer. 0.99. What is the ratio of the Production index(2004-2006) in Iran in 2000 to that in 2002?
Your answer should be very brief. 0.87. What is the ratio of the Production index(2004-2006) of High income: OECD in 2000 to that in 2003?
Offer a very short reply. 1.02. What is the ratio of the Production index(2004-2006) in Bahrain in 2000 to that in 2003?
Make the answer very short. 1.19. What is the ratio of the Production index(2004-2006) of Denmark in 2000 to that in 2003?
Make the answer very short. 0.99. What is the ratio of the Production index(2004-2006) in Iran in 2000 to that in 2003?
Ensure brevity in your answer.  0.83. What is the ratio of the Production index(2004-2006) in High income: OECD in 2001 to that in 2002?
Your answer should be very brief. 1.01. What is the ratio of the Production index(2004-2006) in Bahrain in 2001 to that in 2002?
Make the answer very short. 0.98. What is the ratio of the Production index(2004-2006) of Iran in 2001 to that in 2002?
Provide a short and direct response. 0.92. What is the ratio of the Production index(2004-2006) in Bahrain in 2001 to that in 2003?
Make the answer very short. 1.02. What is the ratio of the Production index(2004-2006) in Iran in 2001 to that in 2003?
Provide a short and direct response. 0.88. What is the ratio of the Production index(2004-2006) in Bahrain in 2002 to that in 2003?
Your answer should be very brief. 1.03. What is the ratio of the Production index(2004-2006) in Iran in 2002 to that in 2003?
Your answer should be compact. 0.96. What is the difference between the highest and the second highest Production index(2004-2006) in High income: OECD?
Your answer should be very brief. 0.81. What is the difference between the highest and the second highest Production index(2004-2006) of Bahrain?
Provide a succinct answer. 5.72. What is the difference between the highest and the second highest Production index(2004-2006) of Denmark?
Keep it short and to the point. 0.22. What is the difference between the highest and the second highest Production index(2004-2006) in Iran?
Offer a terse response. 3.66. What is the difference between the highest and the lowest Production index(2004-2006) of High income: OECD?
Your answer should be compact. 5.13. What is the difference between the highest and the lowest Production index(2004-2006) in Bahrain?
Offer a very short reply. 25.19. What is the difference between the highest and the lowest Production index(2004-2006) in Denmark?
Offer a very short reply. 3.86. What is the difference between the highest and the lowest Production index(2004-2006) of Iran?
Your answer should be compact. 20.39. 